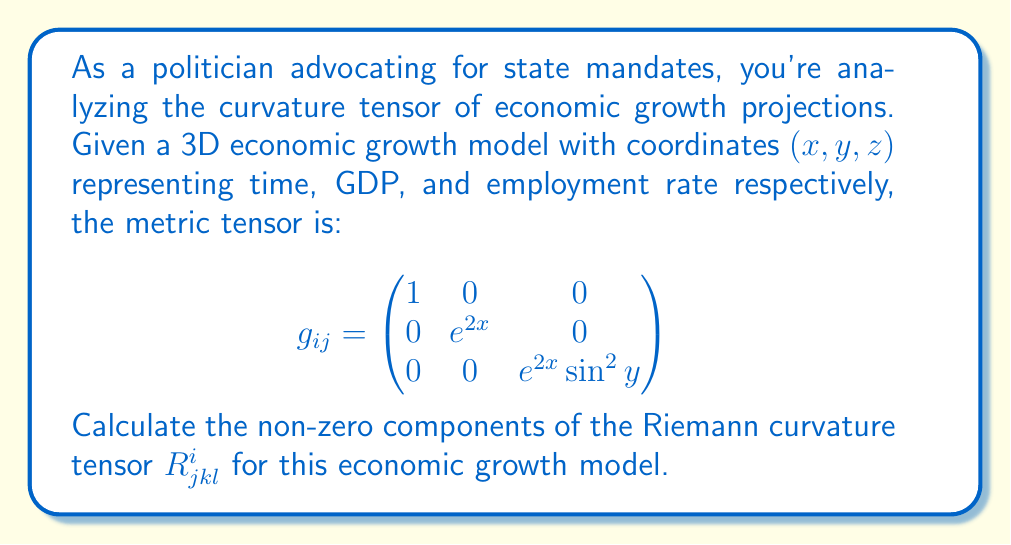Can you answer this question? To calculate the Riemann curvature tensor, we'll follow these steps:

1) First, we need to calculate the Christoffel symbols $\Gamma^i_{jk}$ using the formula:

   $$\Gamma^i_{jk} = \frac{1}{2}g^{im}(\partial_j g_{km} + \partial_k g_{jm} - \partial_m g_{jk})$$

2) The non-zero Christoffel symbols are:
   $$\Gamma^1_{22} = -e^{2x}, \Gamma^1_{33} = -e^{2x}\sin^2y$$
   $$\Gamma^2_{12} = \Gamma^2_{21} = 1$$
   $$\Gamma^3_{13} = \Gamma^3_{31} = 1$$
   $$\Gamma^3_{23} = \Gamma^3_{32} = \cot y$$

3) Now, we can calculate the Riemann curvature tensor using the formula:

   $$R^i_{jkl} = \partial_k \Gamma^i_{jl} - \partial_l \Gamma^i_{jk} + \Gamma^m_{jl}\Gamma^i_{km} - \Gamma^m_{jk}\Gamma^i_{lm}$$

4) The non-zero components are:
   $$R^1_{212} = R^1_{221} = -e^{2x}$$
   $$R^1_{313} = R^1_{331} = -e^{2x}\sin^2y$$
   $$R^2_{323} = R^2_{332} = -e^{2x}\sin^2y$$

5) All other components are either zero or can be derived from these using the symmetry properties of the Riemann tensor.

This curvature tensor describes how the economic growth model deviates from flat Euclidean space, indicating the non-linear relationships between time, GDP, and employment rate in the model.
Answer: $R^1_{212} = R^1_{221} = -e^{2x}$, $R^1_{313} = R^1_{331} = -e^{2x}\sin^2y$, $R^2_{323} = R^2_{332} = -e^{2x}\sin^2y$ 